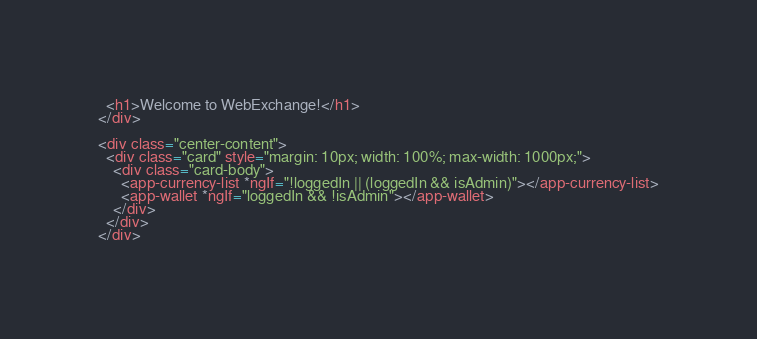Convert code to text. <code><loc_0><loc_0><loc_500><loc_500><_HTML_>  <h1>Welcome to WebExchange!</h1>
</div>

<div class="center-content">
  <div class="card" style="margin: 10px; width: 100%; max-width: 1000px;">
    <div class="card-body">
      <app-currency-list *ngIf="!loggedIn || (loggedIn && isAdmin)"></app-currency-list>
      <app-wallet *ngIf="loggedIn && !isAdmin"></app-wallet>
    </div>
  </div>
</div>
</code> 